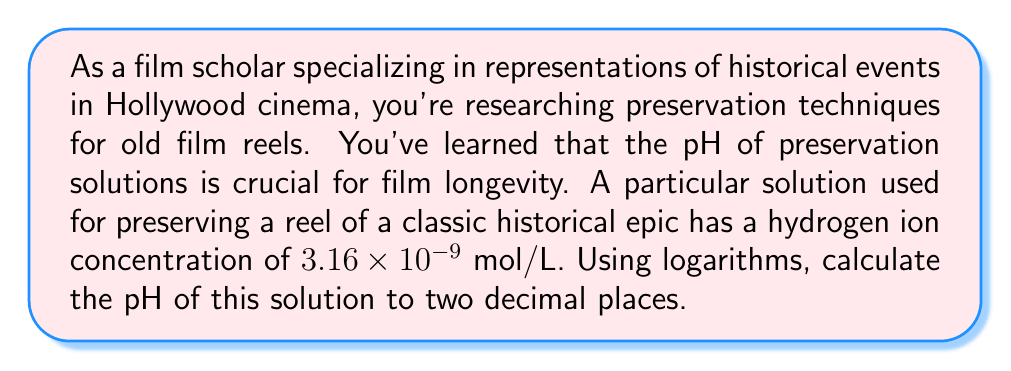Teach me how to tackle this problem. To solve this problem, we'll use the definition of pH and the properties of logarithms:

1) The pH is defined as the negative logarithm (base 10) of the hydrogen ion concentration:

   $$ pH = -\log_{10}[H^+] $$

2) We're given that $[H^+] = 3.16 \times 10^{-9}$ mol/L

3) Substituting this into the pH equation:

   $$ pH = -\log_{10}(3.16 \times 10^{-9}) $$

4) Using the properties of logarithms, we can split this into two parts:

   $$ pH = -(\log_{10}(3.16) + \log_{10}(10^{-9})) $$

5) Simplify:
   $$ pH = -(\log_{10}(3.16) - 9) $$

6) Calculate $\log_{10}(3.16)$ using a calculator: approximately 0.4997

7) Substitute:
   $$ pH = -(0.4997 - 9) = -0.4997 + 9 = 8.5003 $$

8) Rounding to two decimal places: 8.50

This pH indicates that the solution is slightly alkaline, which is often desirable for film preservation as it helps neutralize the acidic byproducts of film degradation.
Answer: The pH of the film preservation solution is 8.50. 